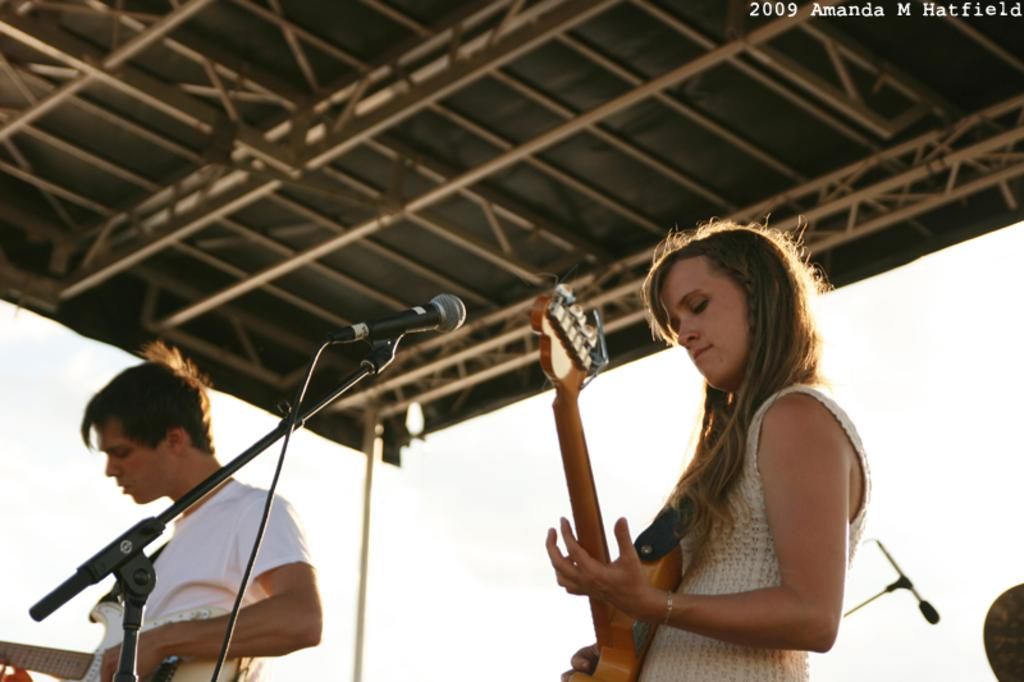How many people are in the image? There are two people in the image, a lady and a male person. What are the people in the image doing? Both the lady and male person are playing a guitar. What object is located in the middle of the image? There is a microphone in the middle of the image. What can be seen at the top of the image? There is a ceiling visible at the top of the image. What type of fruit is being used as a guitar pick in the image? There is no fruit present in the image, nor is any fruit being used as a guitar pick. Is there any quicksand visible in the image? No, there is no quicksand present in the image. 